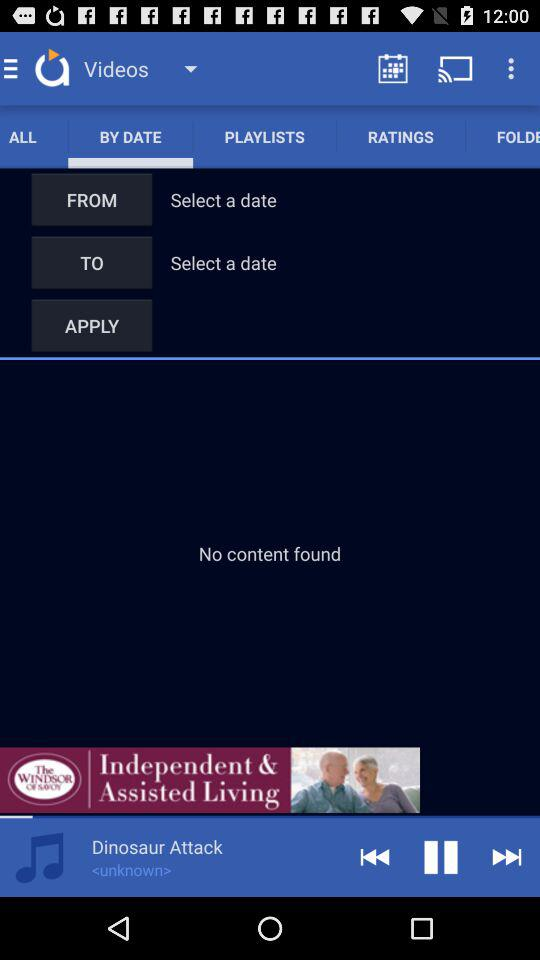Which tab is selected? The selected tab is "BY DATE". 